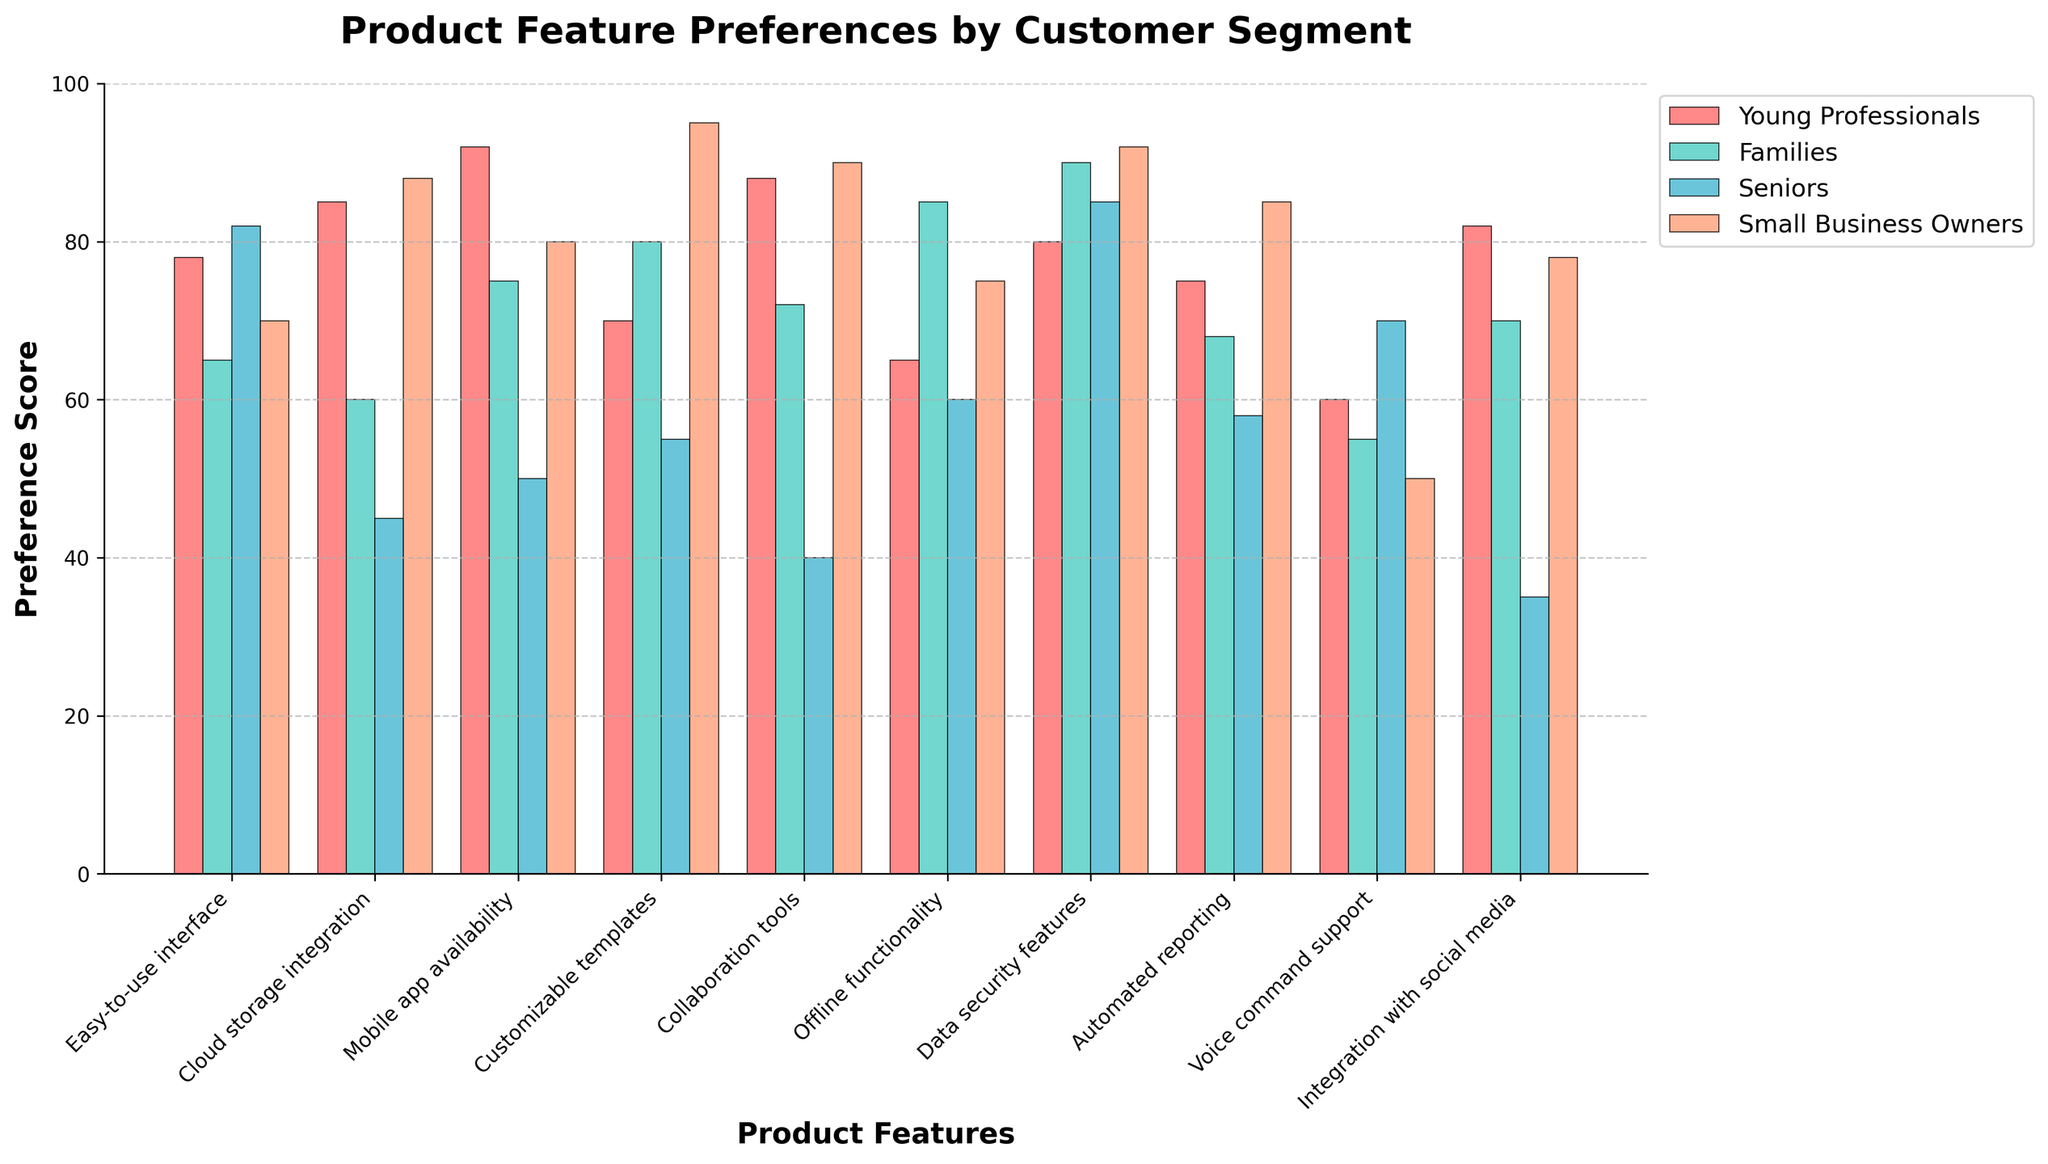What customer segment values cloud storage integration the most? To find the customer segment that values cloud storage integration the most, look at the bars in the "Cloud storage integration" category. The tallest bar represents Small Business Owners with a preference score of 88.
Answer: Small Business Owners Which product feature has the highest preference score among Seniors? To identify the feature with the highest score for Seniors, find the tallest bar in the Seniors' segment across all features. The tallest bar is for "Data security features" with a score of 85.
Answer: Data security features What is the average preference score for Offline functionality across all customer segments? To calculate the average, sum the preference scores for Offline functionality (Young Professionals: 65, Families: 85, Seniors: 60, Small Business Owners: 75) and then divide by the number of segments. (65 + 85 + 60 + 75) / 4 = 71.25.
Answer: 71.25 Which two customer segments have the closest preference scores for Automated reporting? To determine this, compare the preference scores for Automated reporting across all segments (Young Professionals: 75, Families: 68, Seniors: 58, Small Business Owners: 85). The closest scores are between Families (68) and Seniors (58), with a difference of 10.
Answer: Families and Seniors How much higher is the preference for Data security features in Families compared to Young Professionals? Subtract the preference score of Young Professionals for this feature from that of Families. Families: 90, Young Professionals: 80. 90 - 80 = 10.
Answer: 10 Which feature do Small Business Owners prefer the most? To find the most preferred feature for Small Business Owners, locate the tallest bar in their segment across all features. The tallest bar is for "Customizable templates" with a score of 95.
Answer: Customizable templates Rank the features for Young Professionals from most preferred to least preferred. The steps are to list the features in descending order based on their scores for Young Professionals: Mobile app availability (92), Cloud storage integration (85), Collaboration tools (88), Data security features (80), Easy-to-use interface (78), Automated reporting (75), Customizable templates (70), Offline functionality (65), Integration with social media (82), Voice command support (60).
Answer: Mobile app availability, Collaboration tools, Cloud storage integration, Integration with social media, Easy-to-use interface, Data security features, Automated reporting, Customizable templates, Offline functionality, Voice command support 